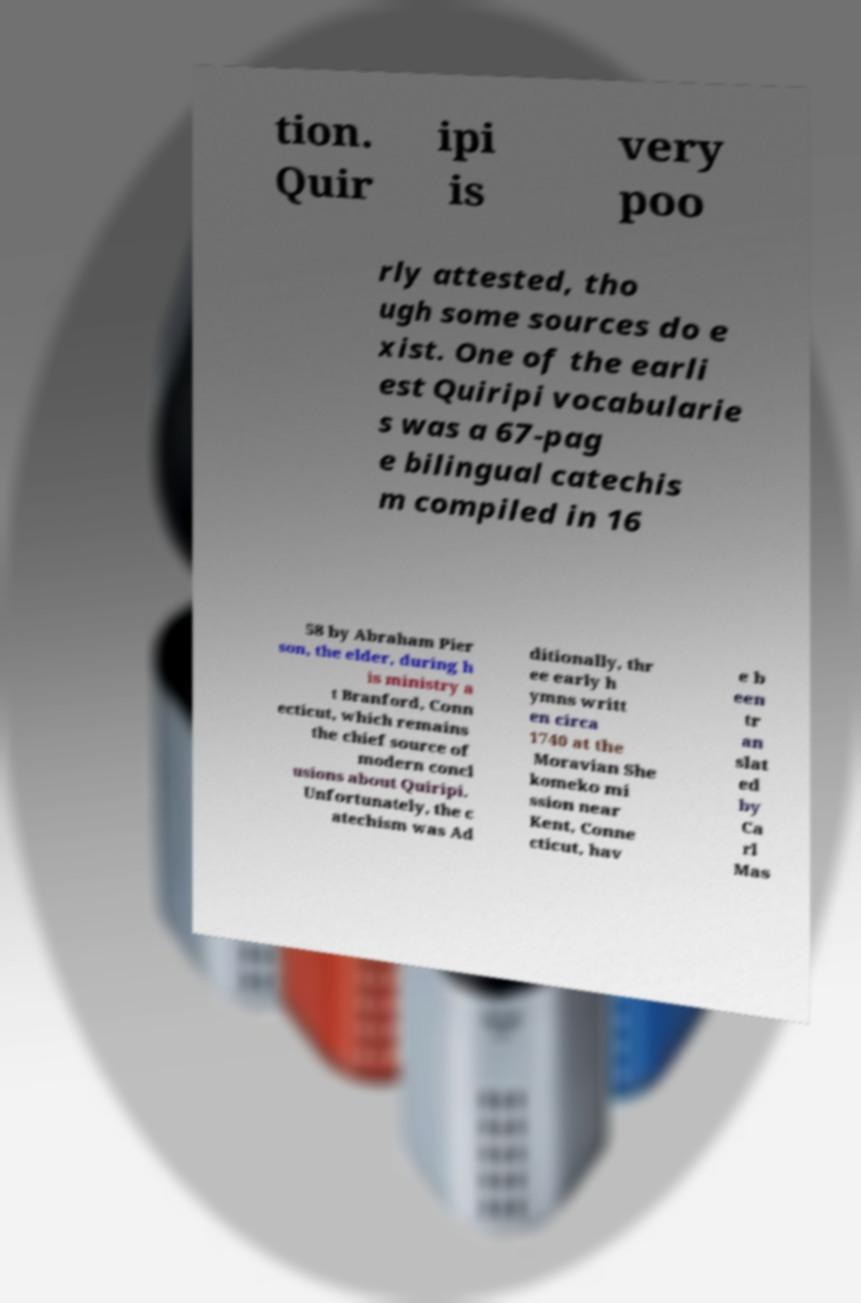Can you read and provide the text displayed in the image?This photo seems to have some interesting text. Can you extract and type it out for me? tion. Quir ipi is very poo rly attested, tho ugh some sources do e xist. One of the earli est Quiripi vocabularie s was a 67-pag e bilingual catechis m compiled in 16 58 by Abraham Pier son, the elder, during h is ministry a t Branford, Conn ecticut, which remains the chief source of modern concl usions about Quiripi. Unfortunately, the c atechism was Ad ditionally, thr ee early h ymns writt en circa 1740 at the Moravian She komeko mi ssion near Kent, Conne cticut, hav e b een tr an slat ed by Ca rl Mas 